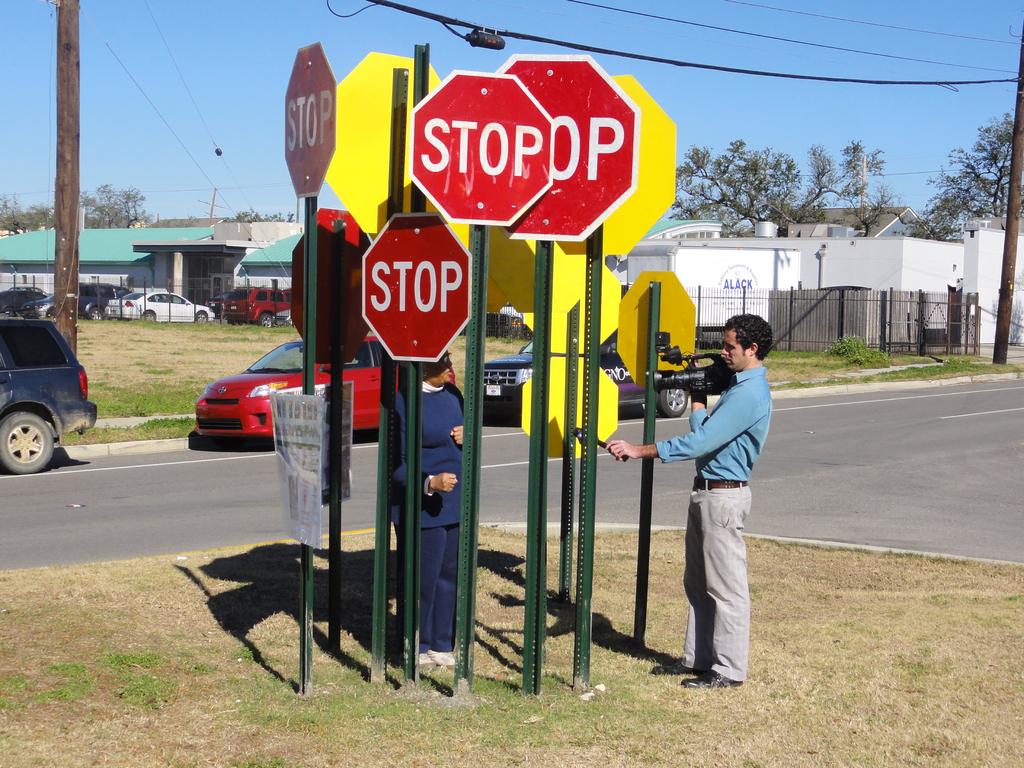What doe the red signs say?
Ensure brevity in your answer.  Stop. 